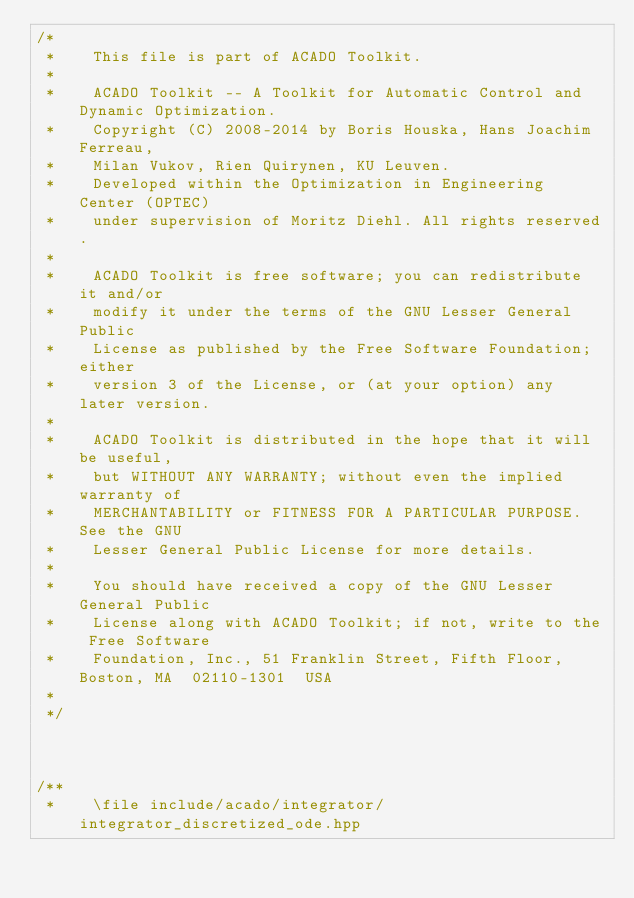<code> <loc_0><loc_0><loc_500><loc_500><_C++_>/*
 *    This file is part of ACADO Toolkit.
 *
 *    ACADO Toolkit -- A Toolkit for Automatic Control and Dynamic Optimization.
 *    Copyright (C) 2008-2014 by Boris Houska, Hans Joachim Ferreau,
 *    Milan Vukov, Rien Quirynen, KU Leuven.
 *    Developed within the Optimization in Engineering Center (OPTEC)
 *    under supervision of Moritz Diehl. All rights reserved.
 *
 *    ACADO Toolkit is free software; you can redistribute it and/or
 *    modify it under the terms of the GNU Lesser General Public
 *    License as published by the Free Software Foundation; either
 *    version 3 of the License, or (at your option) any later version.
 *
 *    ACADO Toolkit is distributed in the hope that it will be useful,
 *    but WITHOUT ANY WARRANTY; without even the implied warranty of
 *    MERCHANTABILITY or FITNESS FOR A PARTICULAR PURPOSE.  See the GNU
 *    Lesser General Public License for more details.
 *
 *    You should have received a copy of the GNU Lesser General Public
 *    License along with ACADO Toolkit; if not, write to the Free Software
 *    Foundation, Inc., 51 Franklin Street, Fifth Floor, Boston, MA  02110-1301  USA
 *
 */



/**
 *    \file include/acado/integrator/integrator_discretized_ode.hpp</code> 